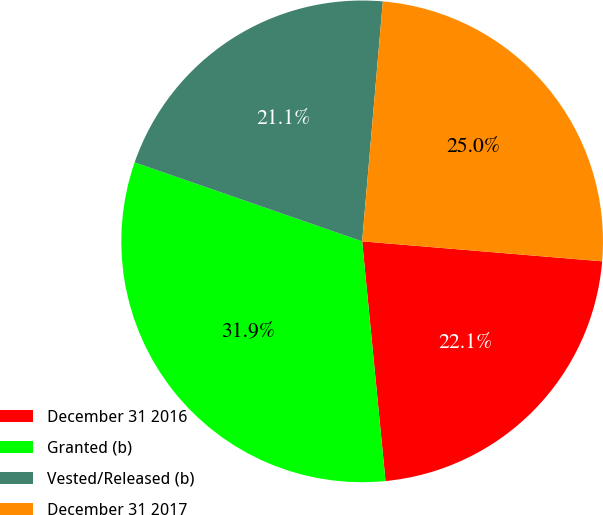<chart> <loc_0><loc_0><loc_500><loc_500><pie_chart><fcel>December 31 2016<fcel>Granted (b)<fcel>Vested/Released (b)<fcel>December 31 2017<nl><fcel>22.13%<fcel>31.86%<fcel>21.05%<fcel>24.95%<nl></chart> 